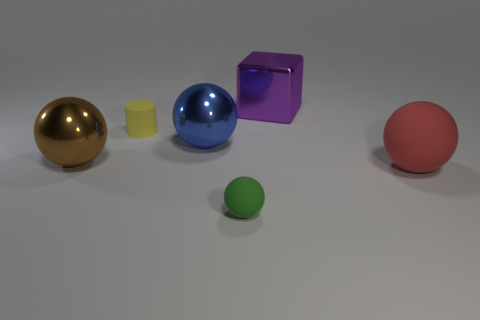There is a metallic object that is behind the matte object that is behind the big blue object; what is its size?
Make the answer very short. Large. What is the color of the small sphere that is made of the same material as the red thing?
Provide a succinct answer. Green. How many metal things are the same size as the brown shiny ball?
Ensure brevity in your answer.  2. What number of blue things are either big shiny objects or tiny objects?
Give a very brief answer. 1. How many objects are either big cyan shiny balls or balls right of the brown metallic sphere?
Ensure brevity in your answer.  3. There is a large sphere that is behind the large brown metallic sphere; what is it made of?
Make the answer very short. Metal. What is the shape of the blue metal thing that is the same size as the purple metal thing?
Give a very brief answer. Sphere. Are there any tiny blue objects of the same shape as the red matte object?
Provide a short and direct response. No. Is the purple cube made of the same material as the tiny object behind the blue shiny sphere?
Provide a short and direct response. No. What material is the cube behind the small rubber object behind the green object made of?
Keep it short and to the point. Metal. 